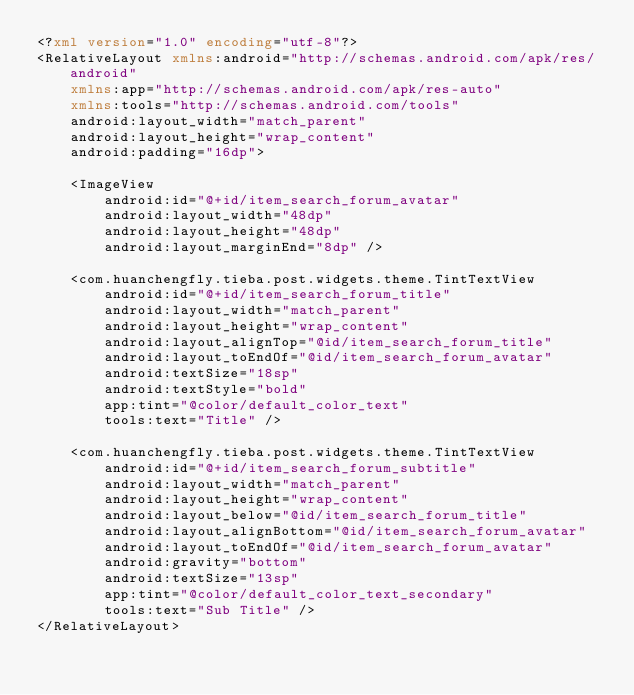Convert code to text. <code><loc_0><loc_0><loc_500><loc_500><_XML_><?xml version="1.0" encoding="utf-8"?>
<RelativeLayout xmlns:android="http://schemas.android.com/apk/res/android"
    xmlns:app="http://schemas.android.com/apk/res-auto"
    xmlns:tools="http://schemas.android.com/tools"
    android:layout_width="match_parent"
    android:layout_height="wrap_content"
    android:padding="16dp">

    <ImageView
        android:id="@+id/item_search_forum_avatar"
        android:layout_width="48dp"
        android:layout_height="48dp"
        android:layout_marginEnd="8dp" />

    <com.huanchengfly.tieba.post.widgets.theme.TintTextView
        android:id="@+id/item_search_forum_title"
        android:layout_width="match_parent"
        android:layout_height="wrap_content"
        android:layout_alignTop="@id/item_search_forum_title"
        android:layout_toEndOf="@id/item_search_forum_avatar"
        android:textSize="18sp"
        android:textStyle="bold"
        app:tint="@color/default_color_text"
        tools:text="Title" />

    <com.huanchengfly.tieba.post.widgets.theme.TintTextView
        android:id="@+id/item_search_forum_subtitle"
        android:layout_width="match_parent"
        android:layout_height="wrap_content"
        android:layout_below="@id/item_search_forum_title"
        android:layout_alignBottom="@id/item_search_forum_avatar"
        android:layout_toEndOf="@id/item_search_forum_avatar"
        android:gravity="bottom"
        android:textSize="13sp"
        app:tint="@color/default_color_text_secondary"
        tools:text="Sub Title" />
</RelativeLayout></code> 